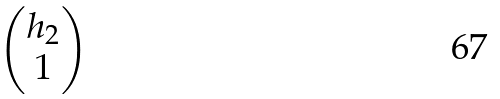Convert formula to latex. <formula><loc_0><loc_0><loc_500><loc_500>\begin{pmatrix} h _ { 2 } \\ 1 \end{pmatrix}</formula> 